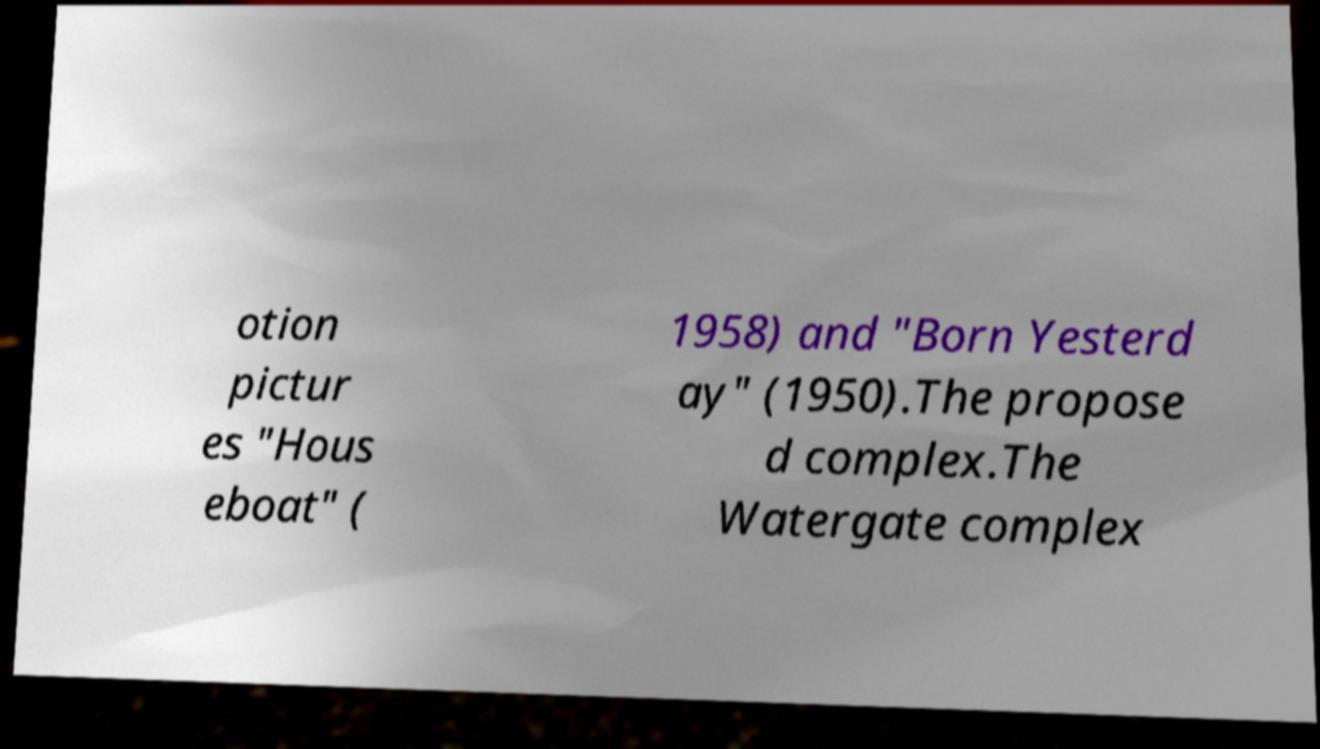Could you extract and type out the text from this image? otion pictur es "Hous eboat" ( 1958) and "Born Yesterd ay" (1950).The propose d complex.The Watergate complex 